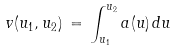Convert formula to latex. <formula><loc_0><loc_0><loc_500><loc_500>v ( u _ { 1 } , u _ { 2 } ) \, = \, \int _ { u _ { 1 } } ^ { u _ { 2 } } a ( u ) \, d u</formula> 